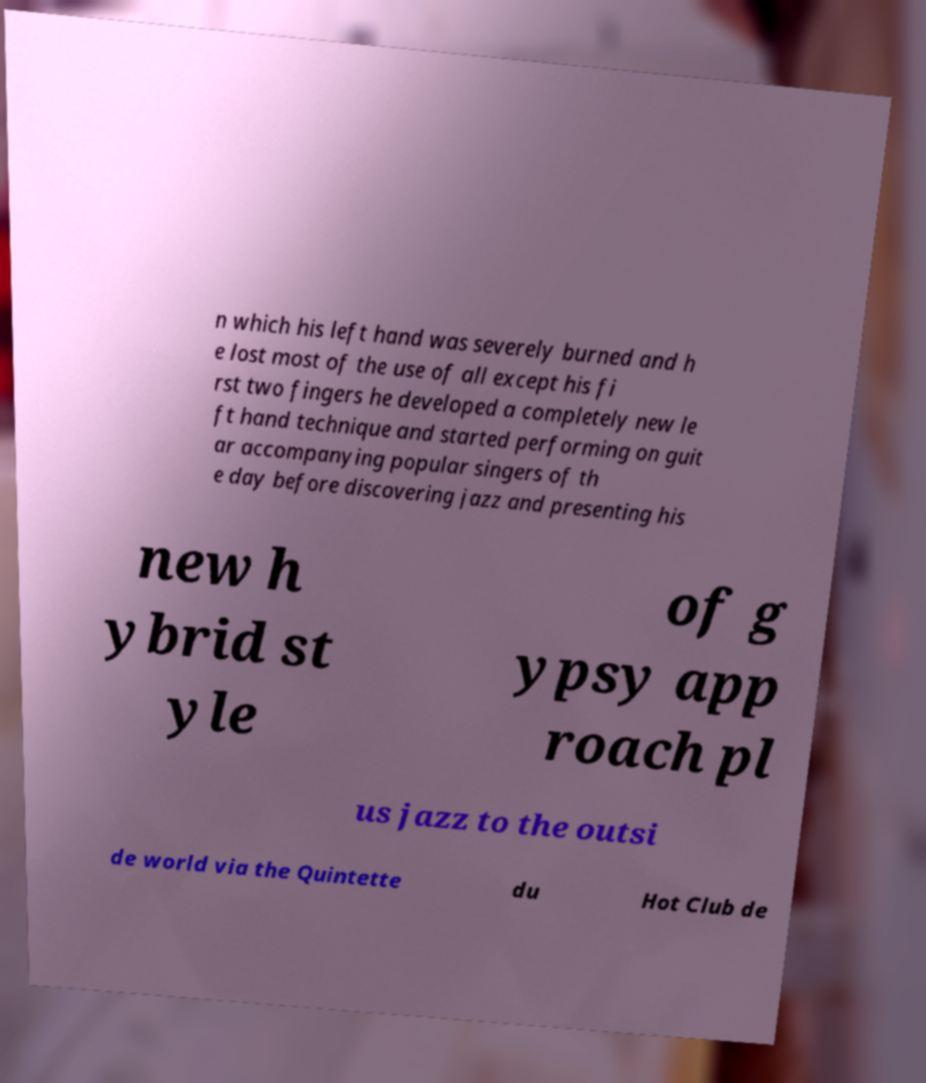I need the written content from this picture converted into text. Can you do that? n which his left hand was severely burned and h e lost most of the use of all except his fi rst two fingers he developed a completely new le ft hand technique and started performing on guit ar accompanying popular singers of th e day before discovering jazz and presenting his new h ybrid st yle of g ypsy app roach pl us jazz to the outsi de world via the Quintette du Hot Club de 